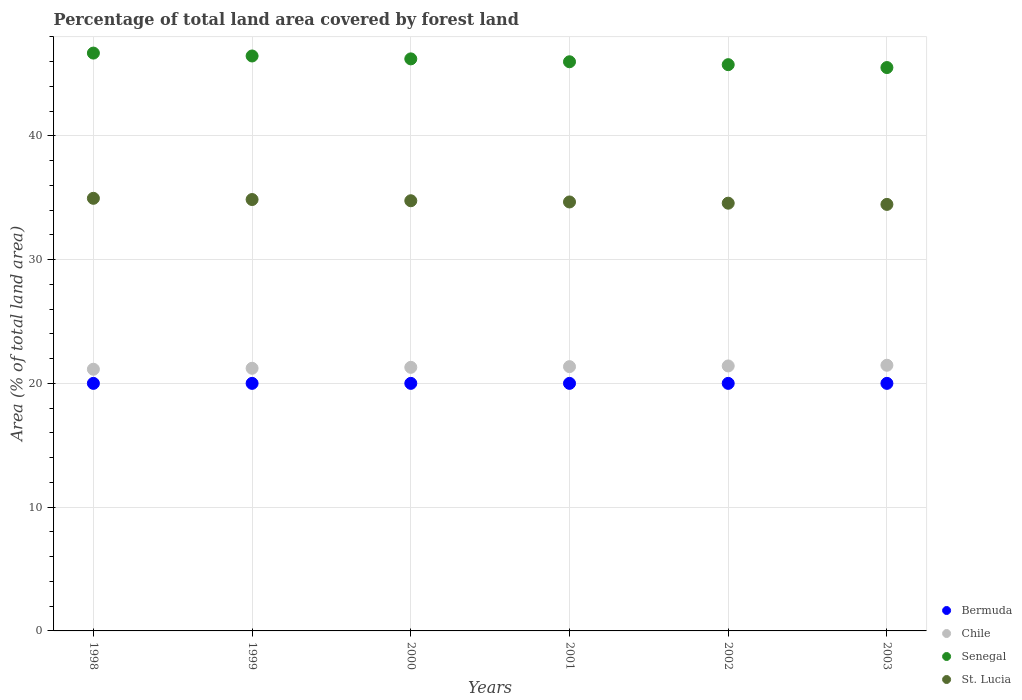How many different coloured dotlines are there?
Make the answer very short. 4. Is the number of dotlines equal to the number of legend labels?
Your answer should be very brief. Yes. What is the percentage of forest land in Bermuda in 1998?
Provide a succinct answer. 20. Across all years, what is the maximum percentage of forest land in Bermuda?
Give a very brief answer. 20. Across all years, what is the minimum percentage of forest land in St. Lucia?
Offer a very short reply. 34.46. What is the total percentage of forest land in Bermuda in the graph?
Keep it short and to the point. 120. What is the difference between the percentage of forest land in St. Lucia in 1999 and that in 2002?
Make the answer very short. 0.3. What is the difference between the percentage of forest land in St. Lucia in 2003 and the percentage of forest land in Bermuda in 2001?
Offer a terse response. 14.46. In the year 2001, what is the difference between the percentage of forest land in Bermuda and percentage of forest land in St. Lucia?
Provide a short and direct response. -14.66. What is the ratio of the percentage of forest land in Senegal in 1999 to that in 2003?
Your answer should be very brief. 1.02. Is the percentage of forest land in Bermuda in 1999 less than that in 2003?
Keep it short and to the point. No. Is the difference between the percentage of forest land in Bermuda in 1998 and 2001 greater than the difference between the percentage of forest land in St. Lucia in 1998 and 2001?
Provide a short and direct response. No. What is the difference between the highest and the second highest percentage of forest land in Senegal?
Keep it short and to the point. 0.23. What is the difference between the highest and the lowest percentage of forest land in St. Lucia?
Offer a very short reply. 0.49. In how many years, is the percentage of forest land in Senegal greater than the average percentage of forest land in Senegal taken over all years?
Offer a very short reply. 3. Is the sum of the percentage of forest land in St. Lucia in 1998 and 2000 greater than the maximum percentage of forest land in Senegal across all years?
Provide a succinct answer. Yes. Is it the case that in every year, the sum of the percentage of forest land in Senegal and percentage of forest land in Bermuda  is greater than the sum of percentage of forest land in St. Lucia and percentage of forest land in Chile?
Your answer should be very brief. No. Does the percentage of forest land in St. Lucia monotonically increase over the years?
Your response must be concise. No. How many dotlines are there?
Your answer should be compact. 4. Are the values on the major ticks of Y-axis written in scientific E-notation?
Offer a terse response. No. Where does the legend appear in the graph?
Make the answer very short. Bottom right. What is the title of the graph?
Your answer should be compact. Percentage of total land area covered by forest land. What is the label or title of the X-axis?
Make the answer very short. Years. What is the label or title of the Y-axis?
Keep it short and to the point. Area (% of total land area). What is the Area (% of total land area) of Chile in 1998?
Your response must be concise. 21.14. What is the Area (% of total land area) in Senegal in 1998?
Provide a short and direct response. 46.68. What is the Area (% of total land area) in St. Lucia in 1998?
Provide a succinct answer. 34.95. What is the Area (% of total land area) of Chile in 1999?
Provide a succinct answer. 21.22. What is the Area (% of total land area) in Senegal in 1999?
Provide a succinct answer. 46.45. What is the Area (% of total land area) of St. Lucia in 1999?
Provide a succinct answer. 34.85. What is the Area (% of total land area) in Chile in 2000?
Your answer should be compact. 21.3. What is the Area (% of total land area) of Senegal in 2000?
Ensure brevity in your answer.  46.22. What is the Area (% of total land area) in St. Lucia in 2000?
Offer a terse response. 34.75. What is the Area (% of total land area) of Bermuda in 2001?
Provide a succinct answer. 20. What is the Area (% of total land area) of Chile in 2001?
Provide a succinct answer. 21.35. What is the Area (% of total land area) of Senegal in 2001?
Provide a succinct answer. 45.98. What is the Area (% of total land area) in St. Lucia in 2001?
Provide a succinct answer. 34.66. What is the Area (% of total land area) in Chile in 2002?
Ensure brevity in your answer.  21.41. What is the Area (% of total land area) in Senegal in 2002?
Give a very brief answer. 45.75. What is the Area (% of total land area) in St. Lucia in 2002?
Offer a very short reply. 34.56. What is the Area (% of total land area) in Bermuda in 2003?
Give a very brief answer. 20. What is the Area (% of total land area) of Chile in 2003?
Provide a succinct answer. 21.46. What is the Area (% of total land area) in Senegal in 2003?
Provide a short and direct response. 45.51. What is the Area (% of total land area) of St. Lucia in 2003?
Offer a very short reply. 34.46. Across all years, what is the maximum Area (% of total land area) in Chile?
Provide a short and direct response. 21.46. Across all years, what is the maximum Area (% of total land area) in Senegal?
Offer a very short reply. 46.68. Across all years, what is the maximum Area (% of total land area) of St. Lucia?
Provide a succinct answer. 34.95. Across all years, what is the minimum Area (% of total land area) of Bermuda?
Offer a very short reply. 20. Across all years, what is the minimum Area (% of total land area) of Chile?
Offer a terse response. 21.14. Across all years, what is the minimum Area (% of total land area) in Senegal?
Offer a terse response. 45.51. Across all years, what is the minimum Area (% of total land area) of St. Lucia?
Offer a very short reply. 34.46. What is the total Area (% of total land area) in Bermuda in the graph?
Give a very brief answer. 120. What is the total Area (% of total land area) of Chile in the graph?
Offer a very short reply. 127.88. What is the total Area (% of total land area) of Senegal in the graph?
Keep it short and to the point. 276.6. What is the total Area (% of total land area) of St. Lucia in the graph?
Your answer should be very brief. 208.23. What is the difference between the Area (% of total land area) in Chile in 1998 and that in 1999?
Offer a terse response. -0.08. What is the difference between the Area (% of total land area) in Senegal in 1998 and that in 1999?
Give a very brief answer. 0.23. What is the difference between the Area (% of total land area) of St. Lucia in 1998 and that in 1999?
Ensure brevity in your answer.  0.1. What is the difference between the Area (% of total land area) of Chile in 1998 and that in 2000?
Provide a short and direct response. -0.15. What is the difference between the Area (% of total land area) in Senegal in 1998 and that in 2000?
Provide a short and direct response. 0.47. What is the difference between the Area (% of total land area) of St. Lucia in 1998 and that in 2000?
Give a very brief answer. 0.2. What is the difference between the Area (% of total land area) in Bermuda in 1998 and that in 2001?
Your answer should be compact. 0. What is the difference between the Area (% of total land area) of Chile in 1998 and that in 2001?
Your answer should be compact. -0.21. What is the difference between the Area (% of total land area) of Senegal in 1998 and that in 2001?
Your answer should be compact. 0.7. What is the difference between the Area (% of total land area) of St. Lucia in 1998 and that in 2001?
Keep it short and to the point. 0.3. What is the difference between the Area (% of total land area) in Bermuda in 1998 and that in 2002?
Offer a very short reply. 0. What is the difference between the Area (% of total land area) in Chile in 1998 and that in 2002?
Your answer should be compact. -0.27. What is the difference between the Area (% of total land area) of Senegal in 1998 and that in 2002?
Ensure brevity in your answer.  0.93. What is the difference between the Area (% of total land area) in St. Lucia in 1998 and that in 2002?
Provide a succinct answer. 0.39. What is the difference between the Area (% of total land area) of Chile in 1998 and that in 2003?
Your answer should be compact. -0.32. What is the difference between the Area (% of total land area) of Senegal in 1998 and that in 2003?
Give a very brief answer. 1.17. What is the difference between the Area (% of total land area) in St. Lucia in 1998 and that in 2003?
Your answer should be very brief. 0.49. What is the difference between the Area (% of total land area) in Chile in 1999 and that in 2000?
Your response must be concise. -0.08. What is the difference between the Area (% of total land area) of Senegal in 1999 and that in 2000?
Provide a succinct answer. 0.23. What is the difference between the Area (% of total land area) in St. Lucia in 1999 and that in 2000?
Offer a very short reply. 0.1. What is the difference between the Area (% of total land area) of Bermuda in 1999 and that in 2001?
Keep it short and to the point. 0. What is the difference between the Area (% of total land area) in Chile in 1999 and that in 2001?
Ensure brevity in your answer.  -0.13. What is the difference between the Area (% of total land area) in Senegal in 1999 and that in 2001?
Provide a succinct answer. 0.47. What is the difference between the Area (% of total land area) in St. Lucia in 1999 and that in 2001?
Your answer should be very brief. 0.2. What is the difference between the Area (% of total land area) in Chile in 1999 and that in 2002?
Give a very brief answer. -0.19. What is the difference between the Area (% of total land area) of Senegal in 1999 and that in 2002?
Your answer should be very brief. 0.7. What is the difference between the Area (% of total land area) in St. Lucia in 1999 and that in 2002?
Make the answer very short. 0.3. What is the difference between the Area (% of total land area) of Bermuda in 1999 and that in 2003?
Make the answer very short. 0. What is the difference between the Area (% of total land area) in Chile in 1999 and that in 2003?
Your answer should be very brief. -0.24. What is the difference between the Area (% of total land area) of Senegal in 1999 and that in 2003?
Give a very brief answer. 0.93. What is the difference between the Area (% of total land area) in St. Lucia in 1999 and that in 2003?
Provide a short and direct response. 0.39. What is the difference between the Area (% of total land area) in Chile in 2000 and that in 2001?
Your answer should be compact. -0.06. What is the difference between the Area (% of total land area) in Senegal in 2000 and that in 2001?
Offer a very short reply. 0.23. What is the difference between the Area (% of total land area) in St. Lucia in 2000 and that in 2001?
Ensure brevity in your answer.  0.1. What is the difference between the Area (% of total land area) of Bermuda in 2000 and that in 2002?
Ensure brevity in your answer.  0. What is the difference between the Area (% of total land area) in Chile in 2000 and that in 2002?
Offer a very short reply. -0.11. What is the difference between the Area (% of total land area) in Senegal in 2000 and that in 2002?
Give a very brief answer. 0.47. What is the difference between the Area (% of total land area) in St. Lucia in 2000 and that in 2002?
Provide a succinct answer. 0.2. What is the difference between the Area (% of total land area) of Chile in 2000 and that in 2003?
Provide a succinct answer. -0.17. What is the difference between the Area (% of total land area) of Senegal in 2000 and that in 2003?
Your answer should be compact. 0.7. What is the difference between the Area (% of total land area) in St. Lucia in 2000 and that in 2003?
Ensure brevity in your answer.  0.3. What is the difference between the Area (% of total land area) of Chile in 2001 and that in 2002?
Offer a very short reply. -0.06. What is the difference between the Area (% of total land area) of Senegal in 2001 and that in 2002?
Ensure brevity in your answer.  0.23. What is the difference between the Area (% of total land area) in St. Lucia in 2001 and that in 2002?
Provide a succinct answer. 0.1. What is the difference between the Area (% of total land area) of Chile in 2001 and that in 2003?
Offer a very short reply. -0.11. What is the difference between the Area (% of total land area) in Senegal in 2001 and that in 2003?
Keep it short and to the point. 0.47. What is the difference between the Area (% of total land area) in St. Lucia in 2001 and that in 2003?
Your answer should be compact. 0.2. What is the difference between the Area (% of total land area) in Bermuda in 2002 and that in 2003?
Provide a succinct answer. 0. What is the difference between the Area (% of total land area) in Chile in 2002 and that in 2003?
Keep it short and to the point. -0.06. What is the difference between the Area (% of total land area) of Senegal in 2002 and that in 2003?
Your answer should be compact. 0.23. What is the difference between the Area (% of total land area) of St. Lucia in 2002 and that in 2003?
Give a very brief answer. 0.1. What is the difference between the Area (% of total land area) in Bermuda in 1998 and the Area (% of total land area) in Chile in 1999?
Ensure brevity in your answer.  -1.22. What is the difference between the Area (% of total land area) in Bermuda in 1998 and the Area (% of total land area) in Senegal in 1999?
Make the answer very short. -26.45. What is the difference between the Area (% of total land area) of Bermuda in 1998 and the Area (% of total land area) of St. Lucia in 1999?
Provide a short and direct response. -14.85. What is the difference between the Area (% of total land area) of Chile in 1998 and the Area (% of total land area) of Senegal in 1999?
Your answer should be very brief. -25.31. What is the difference between the Area (% of total land area) of Chile in 1998 and the Area (% of total land area) of St. Lucia in 1999?
Make the answer very short. -13.71. What is the difference between the Area (% of total land area) of Senegal in 1998 and the Area (% of total land area) of St. Lucia in 1999?
Make the answer very short. 11.83. What is the difference between the Area (% of total land area) of Bermuda in 1998 and the Area (% of total land area) of Chile in 2000?
Ensure brevity in your answer.  -1.3. What is the difference between the Area (% of total land area) of Bermuda in 1998 and the Area (% of total land area) of Senegal in 2000?
Offer a terse response. -26.22. What is the difference between the Area (% of total land area) in Bermuda in 1998 and the Area (% of total land area) in St. Lucia in 2000?
Keep it short and to the point. -14.75. What is the difference between the Area (% of total land area) of Chile in 1998 and the Area (% of total land area) of Senegal in 2000?
Your response must be concise. -25.07. What is the difference between the Area (% of total land area) of Chile in 1998 and the Area (% of total land area) of St. Lucia in 2000?
Your answer should be compact. -13.61. What is the difference between the Area (% of total land area) of Senegal in 1998 and the Area (% of total land area) of St. Lucia in 2000?
Offer a terse response. 11.93. What is the difference between the Area (% of total land area) in Bermuda in 1998 and the Area (% of total land area) in Chile in 2001?
Ensure brevity in your answer.  -1.35. What is the difference between the Area (% of total land area) of Bermuda in 1998 and the Area (% of total land area) of Senegal in 2001?
Offer a terse response. -25.98. What is the difference between the Area (% of total land area) in Bermuda in 1998 and the Area (% of total land area) in St. Lucia in 2001?
Offer a very short reply. -14.66. What is the difference between the Area (% of total land area) in Chile in 1998 and the Area (% of total land area) in Senegal in 2001?
Give a very brief answer. -24.84. What is the difference between the Area (% of total land area) in Chile in 1998 and the Area (% of total land area) in St. Lucia in 2001?
Your answer should be compact. -13.51. What is the difference between the Area (% of total land area) in Senegal in 1998 and the Area (% of total land area) in St. Lucia in 2001?
Offer a very short reply. 12.03. What is the difference between the Area (% of total land area) in Bermuda in 1998 and the Area (% of total land area) in Chile in 2002?
Offer a terse response. -1.41. What is the difference between the Area (% of total land area) of Bermuda in 1998 and the Area (% of total land area) of Senegal in 2002?
Offer a very short reply. -25.75. What is the difference between the Area (% of total land area) of Bermuda in 1998 and the Area (% of total land area) of St. Lucia in 2002?
Your response must be concise. -14.56. What is the difference between the Area (% of total land area) of Chile in 1998 and the Area (% of total land area) of Senegal in 2002?
Ensure brevity in your answer.  -24.61. What is the difference between the Area (% of total land area) of Chile in 1998 and the Area (% of total land area) of St. Lucia in 2002?
Provide a short and direct response. -13.42. What is the difference between the Area (% of total land area) in Senegal in 1998 and the Area (% of total land area) in St. Lucia in 2002?
Provide a succinct answer. 12.13. What is the difference between the Area (% of total land area) of Bermuda in 1998 and the Area (% of total land area) of Chile in 2003?
Provide a succinct answer. -1.46. What is the difference between the Area (% of total land area) in Bermuda in 1998 and the Area (% of total land area) in Senegal in 2003?
Offer a very short reply. -25.52. What is the difference between the Area (% of total land area) in Bermuda in 1998 and the Area (% of total land area) in St. Lucia in 2003?
Offer a terse response. -14.46. What is the difference between the Area (% of total land area) of Chile in 1998 and the Area (% of total land area) of Senegal in 2003?
Offer a terse response. -24.37. What is the difference between the Area (% of total land area) in Chile in 1998 and the Area (% of total land area) in St. Lucia in 2003?
Ensure brevity in your answer.  -13.32. What is the difference between the Area (% of total land area) of Senegal in 1998 and the Area (% of total land area) of St. Lucia in 2003?
Your answer should be compact. 12.22. What is the difference between the Area (% of total land area) in Bermuda in 1999 and the Area (% of total land area) in Chile in 2000?
Ensure brevity in your answer.  -1.3. What is the difference between the Area (% of total land area) in Bermuda in 1999 and the Area (% of total land area) in Senegal in 2000?
Keep it short and to the point. -26.22. What is the difference between the Area (% of total land area) in Bermuda in 1999 and the Area (% of total land area) in St. Lucia in 2000?
Ensure brevity in your answer.  -14.75. What is the difference between the Area (% of total land area) of Chile in 1999 and the Area (% of total land area) of Senegal in 2000?
Provide a short and direct response. -25. What is the difference between the Area (% of total land area) of Chile in 1999 and the Area (% of total land area) of St. Lucia in 2000?
Your answer should be very brief. -13.54. What is the difference between the Area (% of total land area) in Senegal in 1999 and the Area (% of total land area) in St. Lucia in 2000?
Offer a very short reply. 11.7. What is the difference between the Area (% of total land area) in Bermuda in 1999 and the Area (% of total land area) in Chile in 2001?
Your response must be concise. -1.35. What is the difference between the Area (% of total land area) of Bermuda in 1999 and the Area (% of total land area) of Senegal in 2001?
Your answer should be very brief. -25.98. What is the difference between the Area (% of total land area) in Bermuda in 1999 and the Area (% of total land area) in St. Lucia in 2001?
Your answer should be compact. -14.66. What is the difference between the Area (% of total land area) in Chile in 1999 and the Area (% of total land area) in Senegal in 2001?
Offer a very short reply. -24.76. What is the difference between the Area (% of total land area) of Chile in 1999 and the Area (% of total land area) of St. Lucia in 2001?
Provide a succinct answer. -13.44. What is the difference between the Area (% of total land area) of Senegal in 1999 and the Area (% of total land area) of St. Lucia in 2001?
Make the answer very short. 11.79. What is the difference between the Area (% of total land area) of Bermuda in 1999 and the Area (% of total land area) of Chile in 2002?
Ensure brevity in your answer.  -1.41. What is the difference between the Area (% of total land area) of Bermuda in 1999 and the Area (% of total land area) of Senegal in 2002?
Offer a terse response. -25.75. What is the difference between the Area (% of total land area) of Bermuda in 1999 and the Area (% of total land area) of St. Lucia in 2002?
Your answer should be compact. -14.56. What is the difference between the Area (% of total land area) in Chile in 1999 and the Area (% of total land area) in Senegal in 2002?
Give a very brief answer. -24.53. What is the difference between the Area (% of total land area) of Chile in 1999 and the Area (% of total land area) of St. Lucia in 2002?
Your response must be concise. -13.34. What is the difference between the Area (% of total land area) in Senegal in 1999 and the Area (% of total land area) in St. Lucia in 2002?
Your answer should be very brief. 11.89. What is the difference between the Area (% of total land area) of Bermuda in 1999 and the Area (% of total land area) of Chile in 2003?
Make the answer very short. -1.46. What is the difference between the Area (% of total land area) of Bermuda in 1999 and the Area (% of total land area) of Senegal in 2003?
Give a very brief answer. -25.52. What is the difference between the Area (% of total land area) of Bermuda in 1999 and the Area (% of total land area) of St. Lucia in 2003?
Your answer should be compact. -14.46. What is the difference between the Area (% of total land area) in Chile in 1999 and the Area (% of total land area) in Senegal in 2003?
Give a very brief answer. -24.3. What is the difference between the Area (% of total land area) in Chile in 1999 and the Area (% of total land area) in St. Lucia in 2003?
Provide a succinct answer. -13.24. What is the difference between the Area (% of total land area) in Senegal in 1999 and the Area (% of total land area) in St. Lucia in 2003?
Provide a short and direct response. 11.99. What is the difference between the Area (% of total land area) of Bermuda in 2000 and the Area (% of total land area) of Chile in 2001?
Your answer should be very brief. -1.35. What is the difference between the Area (% of total land area) in Bermuda in 2000 and the Area (% of total land area) in Senegal in 2001?
Make the answer very short. -25.98. What is the difference between the Area (% of total land area) in Bermuda in 2000 and the Area (% of total land area) in St. Lucia in 2001?
Give a very brief answer. -14.66. What is the difference between the Area (% of total land area) in Chile in 2000 and the Area (% of total land area) in Senegal in 2001?
Provide a short and direct response. -24.69. What is the difference between the Area (% of total land area) in Chile in 2000 and the Area (% of total land area) in St. Lucia in 2001?
Make the answer very short. -13.36. What is the difference between the Area (% of total land area) of Senegal in 2000 and the Area (% of total land area) of St. Lucia in 2001?
Provide a short and direct response. 11.56. What is the difference between the Area (% of total land area) in Bermuda in 2000 and the Area (% of total land area) in Chile in 2002?
Ensure brevity in your answer.  -1.41. What is the difference between the Area (% of total land area) of Bermuda in 2000 and the Area (% of total land area) of Senegal in 2002?
Your answer should be compact. -25.75. What is the difference between the Area (% of total land area) in Bermuda in 2000 and the Area (% of total land area) in St. Lucia in 2002?
Ensure brevity in your answer.  -14.56. What is the difference between the Area (% of total land area) of Chile in 2000 and the Area (% of total land area) of Senegal in 2002?
Your response must be concise. -24.45. What is the difference between the Area (% of total land area) of Chile in 2000 and the Area (% of total land area) of St. Lucia in 2002?
Your response must be concise. -13.26. What is the difference between the Area (% of total land area) of Senegal in 2000 and the Area (% of total land area) of St. Lucia in 2002?
Give a very brief answer. 11.66. What is the difference between the Area (% of total land area) in Bermuda in 2000 and the Area (% of total land area) in Chile in 2003?
Make the answer very short. -1.46. What is the difference between the Area (% of total land area) of Bermuda in 2000 and the Area (% of total land area) of Senegal in 2003?
Give a very brief answer. -25.52. What is the difference between the Area (% of total land area) in Bermuda in 2000 and the Area (% of total land area) in St. Lucia in 2003?
Your answer should be very brief. -14.46. What is the difference between the Area (% of total land area) in Chile in 2000 and the Area (% of total land area) in Senegal in 2003?
Offer a terse response. -24.22. What is the difference between the Area (% of total land area) in Chile in 2000 and the Area (% of total land area) in St. Lucia in 2003?
Provide a short and direct response. -13.16. What is the difference between the Area (% of total land area) in Senegal in 2000 and the Area (% of total land area) in St. Lucia in 2003?
Keep it short and to the point. 11.76. What is the difference between the Area (% of total land area) of Bermuda in 2001 and the Area (% of total land area) of Chile in 2002?
Keep it short and to the point. -1.41. What is the difference between the Area (% of total land area) of Bermuda in 2001 and the Area (% of total land area) of Senegal in 2002?
Keep it short and to the point. -25.75. What is the difference between the Area (% of total land area) of Bermuda in 2001 and the Area (% of total land area) of St. Lucia in 2002?
Your answer should be very brief. -14.56. What is the difference between the Area (% of total land area) of Chile in 2001 and the Area (% of total land area) of Senegal in 2002?
Offer a terse response. -24.4. What is the difference between the Area (% of total land area) of Chile in 2001 and the Area (% of total land area) of St. Lucia in 2002?
Your answer should be compact. -13.21. What is the difference between the Area (% of total land area) in Senegal in 2001 and the Area (% of total land area) in St. Lucia in 2002?
Your answer should be very brief. 11.43. What is the difference between the Area (% of total land area) of Bermuda in 2001 and the Area (% of total land area) of Chile in 2003?
Offer a very short reply. -1.46. What is the difference between the Area (% of total land area) in Bermuda in 2001 and the Area (% of total land area) in Senegal in 2003?
Provide a succinct answer. -25.52. What is the difference between the Area (% of total land area) in Bermuda in 2001 and the Area (% of total land area) in St. Lucia in 2003?
Provide a short and direct response. -14.46. What is the difference between the Area (% of total land area) of Chile in 2001 and the Area (% of total land area) of Senegal in 2003?
Ensure brevity in your answer.  -24.16. What is the difference between the Area (% of total land area) in Chile in 2001 and the Area (% of total land area) in St. Lucia in 2003?
Ensure brevity in your answer.  -13.11. What is the difference between the Area (% of total land area) in Senegal in 2001 and the Area (% of total land area) in St. Lucia in 2003?
Your response must be concise. 11.52. What is the difference between the Area (% of total land area) of Bermuda in 2002 and the Area (% of total land area) of Chile in 2003?
Keep it short and to the point. -1.46. What is the difference between the Area (% of total land area) in Bermuda in 2002 and the Area (% of total land area) in Senegal in 2003?
Keep it short and to the point. -25.52. What is the difference between the Area (% of total land area) of Bermuda in 2002 and the Area (% of total land area) of St. Lucia in 2003?
Provide a succinct answer. -14.46. What is the difference between the Area (% of total land area) in Chile in 2002 and the Area (% of total land area) in Senegal in 2003?
Your answer should be very brief. -24.11. What is the difference between the Area (% of total land area) in Chile in 2002 and the Area (% of total land area) in St. Lucia in 2003?
Your answer should be compact. -13.05. What is the difference between the Area (% of total land area) of Senegal in 2002 and the Area (% of total land area) of St. Lucia in 2003?
Give a very brief answer. 11.29. What is the average Area (% of total land area) of Chile per year?
Provide a succinct answer. 21.31. What is the average Area (% of total land area) in Senegal per year?
Make the answer very short. 46.1. What is the average Area (% of total land area) in St. Lucia per year?
Provide a short and direct response. 34.7. In the year 1998, what is the difference between the Area (% of total land area) in Bermuda and Area (% of total land area) in Chile?
Provide a succinct answer. -1.14. In the year 1998, what is the difference between the Area (% of total land area) in Bermuda and Area (% of total land area) in Senegal?
Your answer should be very brief. -26.68. In the year 1998, what is the difference between the Area (% of total land area) of Bermuda and Area (% of total land area) of St. Lucia?
Your answer should be very brief. -14.95. In the year 1998, what is the difference between the Area (% of total land area) in Chile and Area (% of total land area) in Senegal?
Give a very brief answer. -25.54. In the year 1998, what is the difference between the Area (% of total land area) in Chile and Area (% of total land area) in St. Lucia?
Keep it short and to the point. -13.81. In the year 1998, what is the difference between the Area (% of total land area) in Senegal and Area (% of total land area) in St. Lucia?
Offer a very short reply. 11.73. In the year 1999, what is the difference between the Area (% of total land area) of Bermuda and Area (% of total land area) of Chile?
Your response must be concise. -1.22. In the year 1999, what is the difference between the Area (% of total land area) in Bermuda and Area (% of total land area) in Senegal?
Your response must be concise. -26.45. In the year 1999, what is the difference between the Area (% of total land area) of Bermuda and Area (% of total land area) of St. Lucia?
Give a very brief answer. -14.85. In the year 1999, what is the difference between the Area (% of total land area) of Chile and Area (% of total land area) of Senegal?
Your answer should be very brief. -25.23. In the year 1999, what is the difference between the Area (% of total land area) in Chile and Area (% of total land area) in St. Lucia?
Give a very brief answer. -13.63. In the year 1999, what is the difference between the Area (% of total land area) of Senegal and Area (% of total land area) of St. Lucia?
Give a very brief answer. 11.6. In the year 2000, what is the difference between the Area (% of total land area) of Bermuda and Area (% of total land area) of Chile?
Give a very brief answer. -1.3. In the year 2000, what is the difference between the Area (% of total land area) of Bermuda and Area (% of total land area) of Senegal?
Give a very brief answer. -26.22. In the year 2000, what is the difference between the Area (% of total land area) in Bermuda and Area (% of total land area) in St. Lucia?
Provide a short and direct response. -14.75. In the year 2000, what is the difference between the Area (% of total land area) in Chile and Area (% of total land area) in Senegal?
Provide a succinct answer. -24.92. In the year 2000, what is the difference between the Area (% of total land area) of Chile and Area (% of total land area) of St. Lucia?
Keep it short and to the point. -13.46. In the year 2000, what is the difference between the Area (% of total land area) in Senegal and Area (% of total land area) in St. Lucia?
Give a very brief answer. 11.46. In the year 2001, what is the difference between the Area (% of total land area) in Bermuda and Area (% of total land area) in Chile?
Provide a succinct answer. -1.35. In the year 2001, what is the difference between the Area (% of total land area) in Bermuda and Area (% of total land area) in Senegal?
Provide a short and direct response. -25.98. In the year 2001, what is the difference between the Area (% of total land area) of Bermuda and Area (% of total land area) of St. Lucia?
Ensure brevity in your answer.  -14.66. In the year 2001, what is the difference between the Area (% of total land area) of Chile and Area (% of total land area) of Senegal?
Make the answer very short. -24.63. In the year 2001, what is the difference between the Area (% of total land area) in Chile and Area (% of total land area) in St. Lucia?
Your answer should be compact. -13.3. In the year 2001, what is the difference between the Area (% of total land area) in Senegal and Area (% of total land area) in St. Lucia?
Offer a terse response. 11.33. In the year 2002, what is the difference between the Area (% of total land area) in Bermuda and Area (% of total land area) in Chile?
Give a very brief answer. -1.41. In the year 2002, what is the difference between the Area (% of total land area) of Bermuda and Area (% of total land area) of Senegal?
Make the answer very short. -25.75. In the year 2002, what is the difference between the Area (% of total land area) in Bermuda and Area (% of total land area) in St. Lucia?
Offer a terse response. -14.56. In the year 2002, what is the difference between the Area (% of total land area) of Chile and Area (% of total land area) of Senegal?
Offer a terse response. -24.34. In the year 2002, what is the difference between the Area (% of total land area) of Chile and Area (% of total land area) of St. Lucia?
Provide a succinct answer. -13.15. In the year 2002, what is the difference between the Area (% of total land area) in Senegal and Area (% of total land area) in St. Lucia?
Offer a very short reply. 11.19. In the year 2003, what is the difference between the Area (% of total land area) in Bermuda and Area (% of total land area) in Chile?
Your answer should be compact. -1.46. In the year 2003, what is the difference between the Area (% of total land area) of Bermuda and Area (% of total land area) of Senegal?
Provide a succinct answer. -25.52. In the year 2003, what is the difference between the Area (% of total land area) in Bermuda and Area (% of total land area) in St. Lucia?
Keep it short and to the point. -14.46. In the year 2003, what is the difference between the Area (% of total land area) in Chile and Area (% of total land area) in Senegal?
Provide a succinct answer. -24.05. In the year 2003, what is the difference between the Area (% of total land area) of Chile and Area (% of total land area) of St. Lucia?
Keep it short and to the point. -13. In the year 2003, what is the difference between the Area (% of total land area) of Senegal and Area (% of total land area) of St. Lucia?
Ensure brevity in your answer.  11.06. What is the ratio of the Area (% of total land area) in Bermuda in 1998 to that in 1999?
Offer a terse response. 1. What is the ratio of the Area (% of total land area) of Chile in 1998 to that in 1999?
Your answer should be very brief. 1. What is the ratio of the Area (% of total land area) in St. Lucia in 1998 to that in 1999?
Ensure brevity in your answer.  1. What is the ratio of the Area (% of total land area) of Chile in 1998 to that in 2000?
Your answer should be very brief. 0.99. What is the ratio of the Area (% of total land area) of St. Lucia in 1998 to that in 2000?
Offer a terse response. 1.01. What is the ratio of the Area (% of total land area) in Chile in 1998 to that in 2001?
Ensure brevity in your answer.  0.99. What is the ratio of the Area (% of total land area) in Senegal in 1998 to that in 2001?
Offer a very short reply. 1.02. What is the ratio of the Area (% of total land area) of St. Lucia in 1998 to that in 2001?
Offer a very short reply. 1.01. What is the ratio of the Area (% of total land area) in Bermuda in 1998 to that in 2002?
Your answer should be compact. 1. What is the ratio of the Area (% of total land area) in Chile in 1998 to that in 2002?
Your answer should be very brief. 0.99. What is the ratio of the Area (% of total land area) of Senegal in 1998 to that in 2002?
Offer a terse response. 1.02. What is the ratio of the Area (% of total land area) of St. Lucia in 1998 to that in 2002?
Provide a short and direct response. 1.01. What is the ratio of the Area (% of total land area) in Senegal in 1998 to that in 2003?
Keep it short and to the point. 1.03. What is the ratio of the Area (% of total land area) of St. Lucia in 1998 to that in 2003?
Your answer should be very brief. 1.01. What is the ratio of the Area (% of total land area) of Bermuda in 1999 to that in 2000?
Make the answer very short. 1. What is the ratio of the Area (% of total land area) of St. Lucia in 1999 to that in 2000?
Keep it short and to the point. 1. What is the ratio of the Area (% of total land area) in Bermuda in 1999 to that in 2001?
Your answer should be very brief. 1. What is the ratio of the Area (% of total land area) in Chile in 1999 to that in 2001?
Your answer should be very brief. 0.99. What is the ratio of the Area (% of total land area) of Senegal in 1999 to that in 2001?
Your answer should be very brief. 1.01. What is the ratio of the Area (% of total land area) of St. Lucia in 1999 to that in 2001?
Make the answer very short. 1.01. What is the ratio of the Area (% of total land area) of Bermuda in 1999 to that in 2002?
Offer a terse response. 1. What is the ratio of the Area (% of total land area) of Chile in 1999 to that in 2002?
Your answer should be very brief. 0.99. What is the ratio of the Area (% of total land area) of Senegal in 1999 to that in 2002?
Ensure brevity in your answer.  1.02. What is the ratio of the Area (% of total land area) in St. Lucia in 1999 to that in 2002?
Your response must be concise. 1.01. What is the ratio of the Area (% of total land area) of Bermuda in 1999 to that in 2003?
Provide a succinct answer. 1. What is the ratio of the Area (% of total land area) in Chile in 1999 to that in 2003?
Offer a terse response. 0.99. What is the ratio of the Area (% of total land area) in Senegal in 1999 to that in 2003?
Your answer should be compact. 1.02. What is the ratio of the Area (% of total land area) of St. Lucia in 1999 to that in 2003?
Make the answer very short. 1.01. What is the ratio of the Area (% of total land area) in Bermuda in 2000 to that in 2001?
Your answer should be compact. 1. What is the ratio of the Area (% of total land area) of Chile in 2000 to that in 2001?
Ensure brevity in your answer.  1. What is the ratio of the Area (% of total land area) of St. Lucia in 2000 to that in 2001?
Provide a succinct answer. 1. What is the ratio of the Area (% of total land area) of Bermuda in 2000 to that in 2002?
Make the answer very short. 1. What is the ratio of the Area (% of total land area) in Senegal in 2000 to that in 2002?
Your response must be concise. 1.01. What is the ratio of the Area (% of total land area) in Senegal in 2000 to that in 2003?
Make the answer very short. 1.02. What is the ratio of the Area (% of total land area) in St. Lucia in 2000 to that in 2003?
Offer a terse response. 1.01. What is the ratio of the Area (% of total land area) of Chile in 2001 to that in 2002?
Make the answer very short. 1. What is the ratio of the Area (% of total land area) of St. Lucia in 2001 to that in 2002?
Provide a short and direct response. 1. What is the ratio of the Area (% of total land area) of Bermuda in 2001 to that in 2003?
Your answer should be compact. 1. What is the ratio of the Area (% of total land area) of Chile in 2001 to that in 2003?
Your answer should be compact. 0.99. What is the ratio of the Area (% of total land area) of Senegal in 2001 to that in 2003?
Offer a terse response. 1.01. What is the ratio of the Area (% of total land area) in St. Lucia in 2001 to that in 2003?
Offer a terse response. 1.01. What is the ratio of the Area (% of total land area) of Chile in 2002 to that in 2003?
Your response must be concise. 1. What is the ratio of the Area (% of total land area) in St. Lucia in 2002 to that in 2003?
Provide a succinct answer. 1. What is the difference between the highest and the second highest Area (% of total land area) of Chile?
Keep it short and to the point. 0.06. What is the difference between the highest and the second highest Area (% of total land area) in Senegal?
Provide a succinct answer. 0.23. What is the difference between the highest and the second highest Area (% of total land area) of St. Lucia?
Offer a terse response. 0.1. What is the difference between the highest and the lowest Area (% of total land area) of Chile?
Your answer should be very brief. 0.32. What is the difference between the highest and the lowest Area (% of total land area) of Senegal?
Offer a terse response. 1.17. What is the difference between the highest and the lowest Area (% of total land area) of St. Lucia?
Provide a short and direct response. 0.49. 